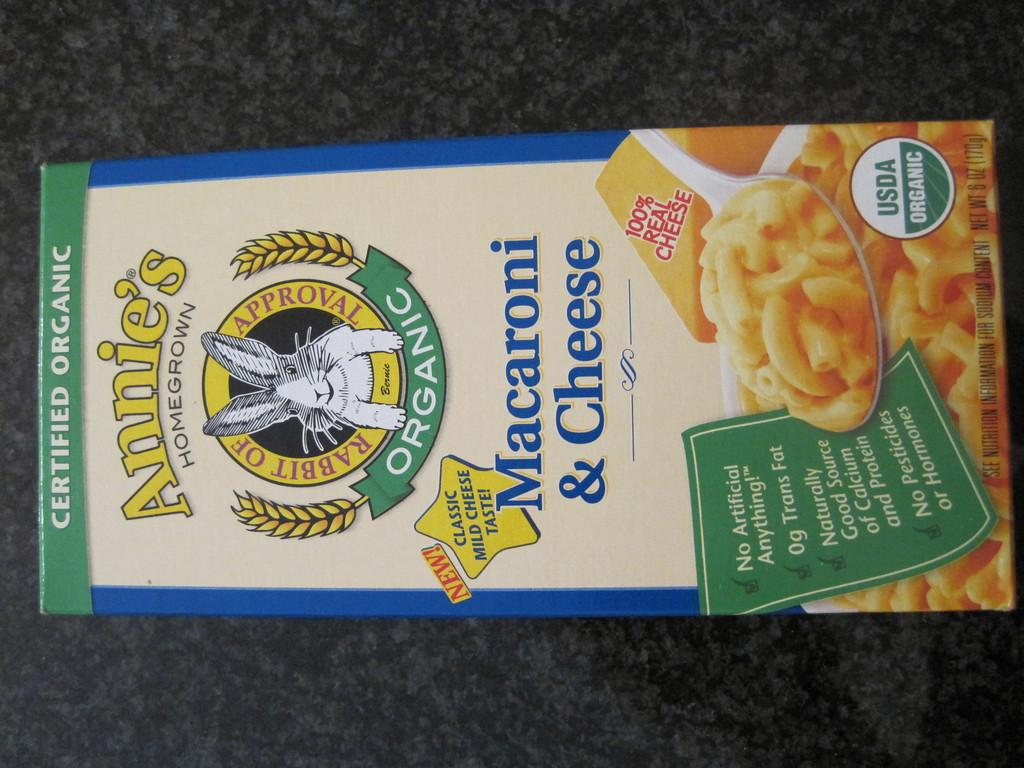What object is located in the middle of the image? There is a box in the image, and it is in the middle. Where is the box placed in the image? The box is on a surface in the image. What type of needle is used to wash the box in the image? There is no needle or washing activity present in the image; it only features a box on a surface. 